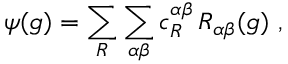Convert formula to latex. <formula><loc_0><loc_0><loc_500><loc_500>\psi ( g ) = \sum _ { R } \sum _ { \alpha \beta } c _ { R } ^ { \alpha \beta } \, R _ { \alpha \beta } ( g ) ,</formula> 